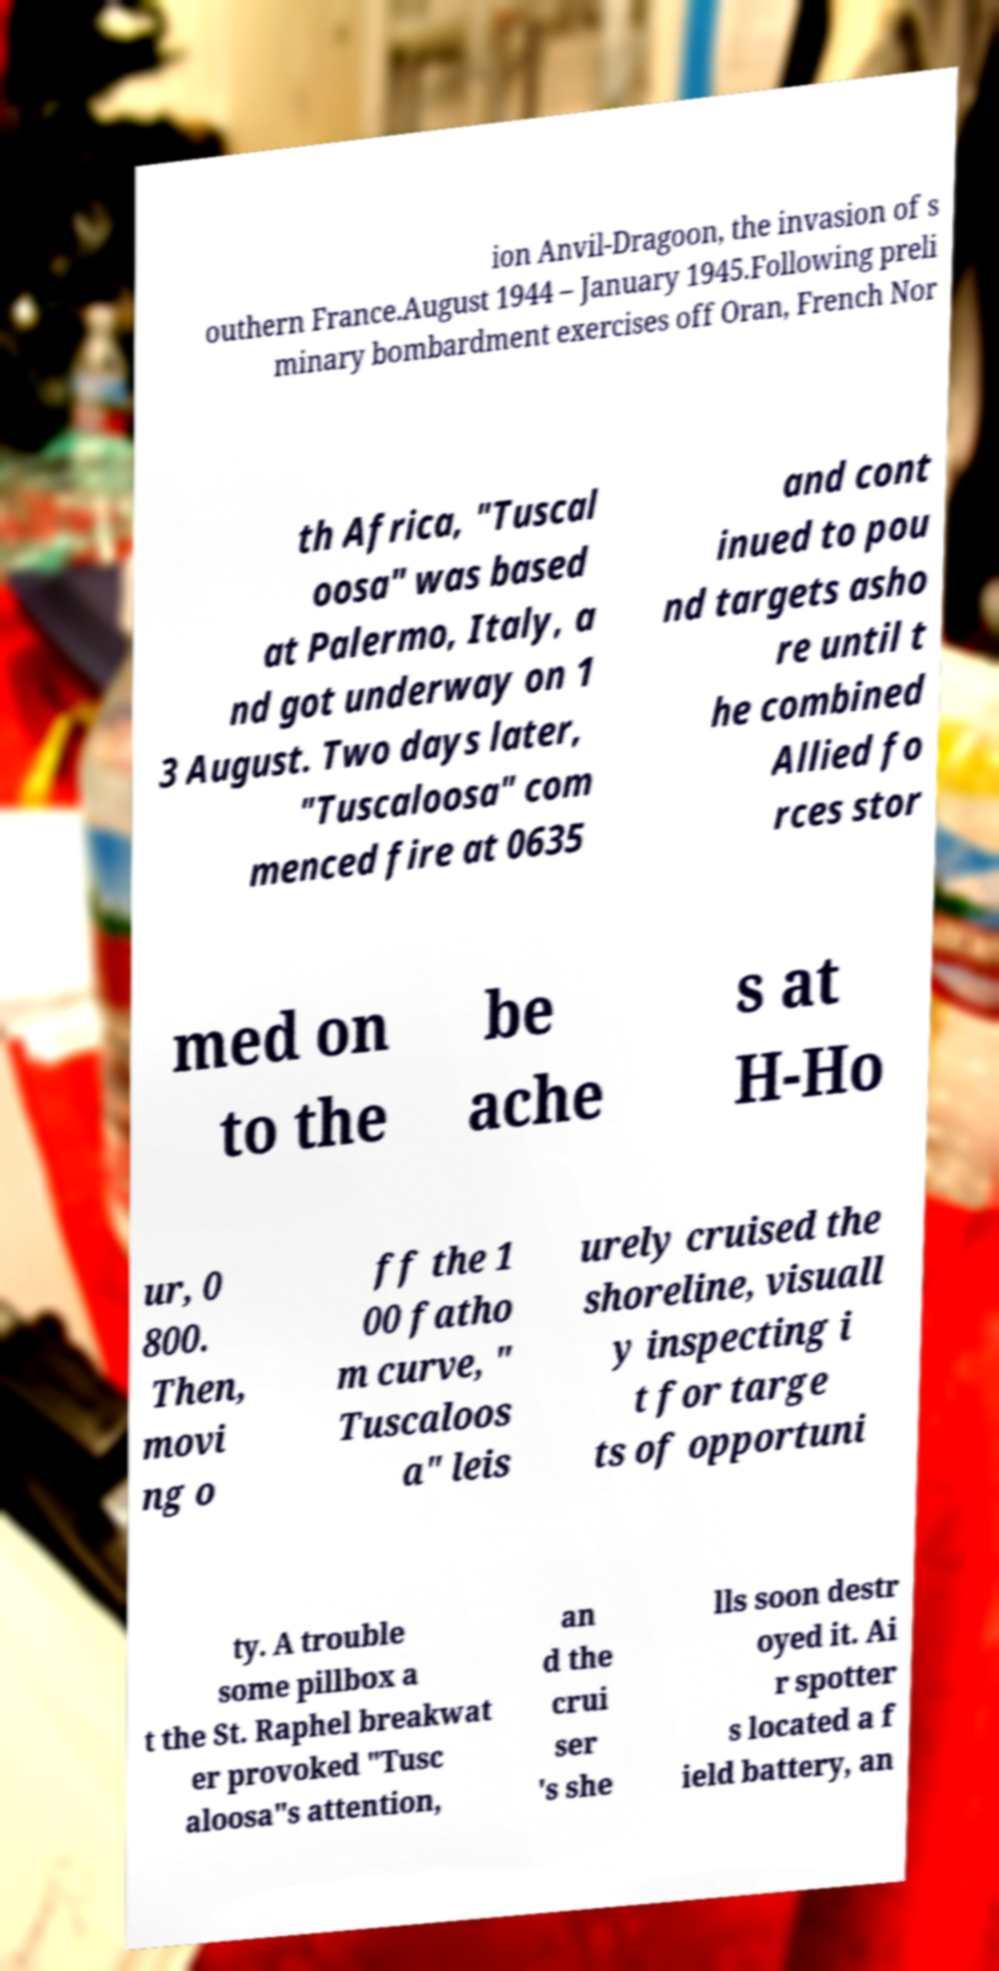I need the written content from this picture converted into text. Can you do that? ion Anvil-Dragoon, the invasion of s outhern France.August 1944 – January 1945.Following preli minary bombardment exercises off Oran, French Nor th Africa, "Tuscal oosa" was based at Palermo, Italy, a nd got underway on 1 3 August. Two days later, "Tuscaloosa" com menced fire at 0635 and cont inued to pou nd targets asho re until t he combined Allied fo rces stor med on to the be ache s at H-Ho ur, 0 800. Then, movi ng o ff the 1 00 fatho m curve, " Tuscaloos a" leis urely cruised the shoreline, visuall y inspecting i t for targe ts of opportuni ty. A trouble some pillbox a t the St. Raphel breakwat er provoked "Tusc aloosa"s attention, an d the crui ser 's she lls soon destr oyed it. Ai r spotter s located a f ield battery, an 